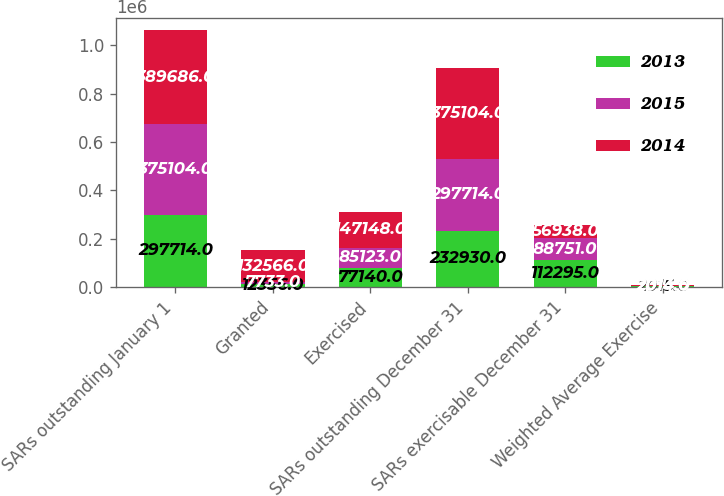Convert chart. <chart><loc_0><loc_0><loc_500><loc_500><stacked_bar_chart><ecel><fcel>SARs outstanding January 1<fcel>Granted<fcel>Exercised<fcel>SARs outstanding December 31<fcel>SARs exercisable December 31<fcel>Weighted Average Exercise<nl><fcel>2013<fcel>297714<fcel>12356<fcel>77140<fcel>232930<fcel>112295<fcel>2015<nl><fcel>2015<fcel>375104<fcel>7733<fcel>85123<fcel>297714<fcel>88751<fcel>2014<nl><fcel>2014<fcel>389686<fcel>132566<fcel>147148<fcel>375104<fcel>56938<fcel>2013<nl></chart> 